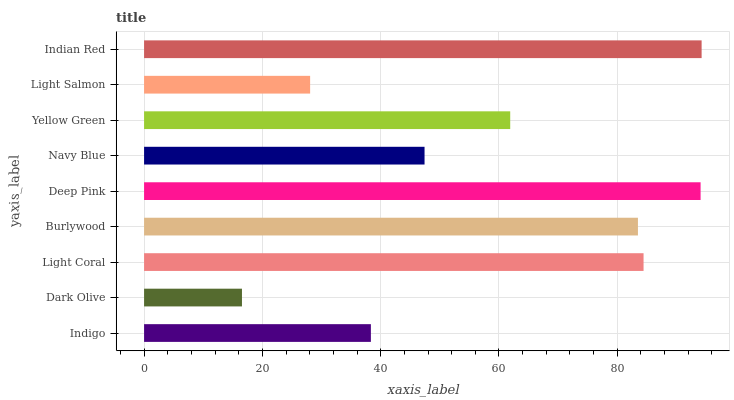Is Dark Olive the minimum?
Answer yes or no. Yes. Is Indian Red the maximum?
Answer yes or no. Yes. Is Light Coral the minimum?
Answer yes or no. No. Is Light Coral the maximum?
Answer yes or no. No. Is Light Coral greater than Dark Olive?
Answer yes or no. Yes. Is Dark Olive less than Light Coral?
Answer yes or no. Yes. Is Dark Olive greater than Light Coral?
Answer yes or no. No. Is Light Coral less than Dark Olive?
Answer yes or no. No. Is Yellow Green the high median?
Answer yes or no. Yes. Is Yellow Green the low median?
Answer yes or no. Yes. Is Indian Red the high median?
Answer yes or no. No. Is Burlywood the low median?
Answer yes or no. No. 